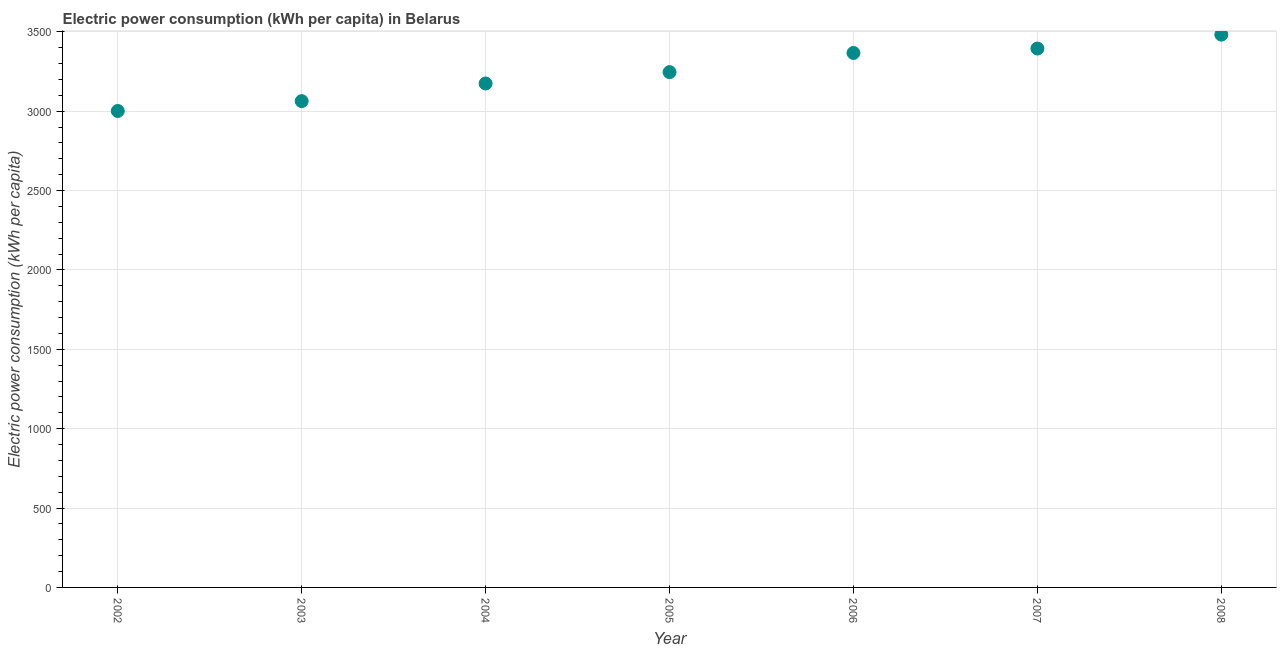What is the electric power consumption in 2007?
Offer a very short reply. 3394.25. Across all years, what is the maximum electric power consumption?
Offer a very short reply. 3481.74. Across all years, what is the minimum electric power consumption?
Your answer should be compact. 3000.91. What is the sum of the electric power consumption?
Your answer should be very brief. 2.27e+04. What is the difference between the electric power consumption in 2004 and 2005?
Your answer should be very brief. -71.58. What is the average electric power consumption per year?
Your response must be concise. 3246.57. What is the median electric power consumption?
Offer a terse response. 3245.68. In how many years, is the electric power consumption greater than 600 kWh per capita?
Keep it short and to the point. 7. What is the ratio of the electric power consumption in 2002 to that in 2008?
Keep it short and to the point. 0.86. Is the electric power consumption in 2007 less than that in 2008?
Offer a terse response. Yes. Is the difference between the electric power consumption in 2002 and 2005 greater than the difference between any two years?
Offer a very short reply. No. What is the difference between the highest and the second highest electric power consumption?
Give a very brief answer. 87.49. What is the difference between the highest and the lowest electric power consumption?
Your answer should be very brief. 480.83. In how many years, is the electric power consumption greater than the average electric power consumption taken over all years?
Keep it short and to the point. 3. Does the electric power consumption monotonically increase over the years?
Your response must be concise. Yes. How many dotlines are there?
Provide a short and direct response. 1. What is the difference between two consecutive major ticks on the Y-axis?
Make the answer very short. 500. Are the values on the major ticks of Y-axis written in scientific E-notation?
Provide a succinct answer. No. What is the title of the graph?
Your answer should be very brief. Electric power consumption (kWh per capita) in Belarus. What is the label or title of the Y-axis?
Your answer should be very brief. Electric power consumption (kWh per capita). What is the Electric power consumption (kWh per capita) in 2002?
Provide a short and direct response. 3000.91. What is the Electric power consumption (kWh per capita) in 2003?
Make the answer very short. 3062.98. What is the Electric power consumption (kWh per capita) in 2004?
Your answer should be very brief. 3174.1. What is the Electric power consumption (kWh per capita) in 2005?
Offer a very short reply. 3245.68. What is the Electric power consumption (kWh per capita) in 2006?
Your answer should be compact. 3366.31. What is the Electric power consumption (kWh per capita) in 2007?
Provide a succinct answer. 3394.25. What is the Electric power consumption (kWh per capita) in 2008?
Your answer should be compact. 3481.74. What is the difference between the Electric power consumption (kWh per capita) in 2002 and 2003?
Offer a very short reply. -62.07. What is the difference between the Electric power consumption (kWh per capita) in 2002 and 2004?
Offer a terse response. -173.19. What is the difference between the Electric power consumption (kWh per capita) in 2002 and 2005?
Provide a succinct answer. -244.77. What is the difference between the Electric power consumption (kWh per capita) in 2002 and 2006?
Provide a short and direct response. -365.39. What is the difference between the Electric power consumption (kWh per capita) in 2002 and 2007?
Provide a short and direct response. -393.33. What is the difference between the Electric power consumption (kWh per capita) in 2002 and 2008?
Provide a succinct answer. -480.83. What is the difference between the Electric power consumption (kWh per capita) in 2003 and 2004?
Provide a short and direct response. -111.12. What is the difference between the Electric power consumption (kWh per capita) in 2003 and 2005?
Provide a succinct answer. -182.7. What is the difference between the Electric power consumption (kWh per capita) in 2003 and 2006?
Provide a short and direct response. -303.33. What is the difference between the Electric power consumption (kWh per capita) in 2003 and 2007?
Your answer should be very brief. -331.27. What is the difference between the Electric power consumption (kWh per capita) in 2003 and 2008?
Offer a terse response. -418.76. What is the difference between the Electric power consumption (kWh per capita) in 2004 and 2005?
Provide a succinct answer. -71.58. What is the difference between the Electric power consumption (kWh per capita) in 2004 and 2006?
Give a very brief answer. -192.2. What is the difference between the Electric power consumption (kWh per capita) in 2004 and 2007?
Offer a terse response. -220.15. What is the difference between the Electric power consumption (kWh per capita) in 2004 and 2008?
Ensure brevity in your answer.  -307.64. What is the difference between the Electric power consumption (kWh per capita) in 2005 and 2006?
Give a very brief answer. -120.63. What is the difference between the Electric power consumption (kWh per capita) in 2005 and 2007?
Offer a terse response. -148.57. What is the difference between the Electric power consumption (kWh per capita) in 2005 and 2008?
Ensure brevity in your answer.  -236.06. What is the difference between the Electric power consumption (kWh per capita) in 2006 and 2007?
Your answer should be compact. -27.94. What is the difference between the Electric power consumption (kWh per capita) in 2006 and 2008?
Provide a short and direct response. -115.43. What is the difference between the Electric power consumption (kWh per capita) in 2007 and 2008?
Provide a succinct answer. -87.49. What is the ratio of the Electric power consumption (kWh per capita) in 2002 to that in 2003?
Provide a short and direct response. 0.98. What is the ratio of the Electric power consumption (kWh per capita) in 2002 to that in 2004?
Your response must be concise. 0.94. What is the ratio of the Electric power consumption (kWh per capita) in 2002 to that in 2005?
Your answer should be compact. 0.93. What is the ratio of the Electric power consumption (kWh per capita) in 2002 to that in 2006?
Make the answer very short. 0.89. What is the ratio of the Electric power consumption (kWh per capita) in 2002 to that in 2007?
Offer a very short reply. 0.88. What is the ratio of the Electric power consumption (kWh per capita) in 2002 to that in 2008?
Offer a very short reply. 0.86. What is the ratio of the Electric power consumption (kWh per capita) in 2003 to that in 2004?
Provide a succinct answer. 0.96. What is the ratio of the Electric power consumption (kWh per capita) in 2003 to that in 2005?
Provide a short and direct response. 0.94. What is the ratio of the Electric power consumption (kWh per capita) in 2003 to that in 2006?
Your answer should be compact. 0.91. What is the ratio of the Electric power consumption (kWh per capita) in 2003 to that in 2007?
Offer a terse response. 0.9. What is the ratio of the Electric power consumption (kWh per capita) in 2003 to that in 2008?
Your response must be concise. 0.88. What is the ratio of the Electric power consumption (kWh per capita) in 2004 to that in 2005?
Provide a short and direct response. 0.98. What is the ratio of the Electric power consumption (kWh per capita) in 2004 to that in 2006?
Provide a short and direct response. 0.94. What is the ratio of the Electric power consumption (kWh per capita) in 2004 to that in 2007?
Your answer should be compact. 0.94. What is the ratio of the Electric power consumption (kWh per capita) in 2004 to that in 2008?
Make the answer very short. 0.91. What is the ratio of the Electric power consumption (kWh per capita) in 2005 to that in 2006?
Your answer should be compact. 0.96. What is the ratio of the Electric power consumption (kWh per capita) in 2005 to that in 2007?
Your answer should be compact. 0.96. What is the ratio of the Electric power consumption (kWh per capita) in 2005 to that in 2008?
Give a very brief answer. 0.93. What is the ratio of the Electric power consumption (kWh per capita) in 2006 to that in 2007?
Give a very brief answer. 0.99. 